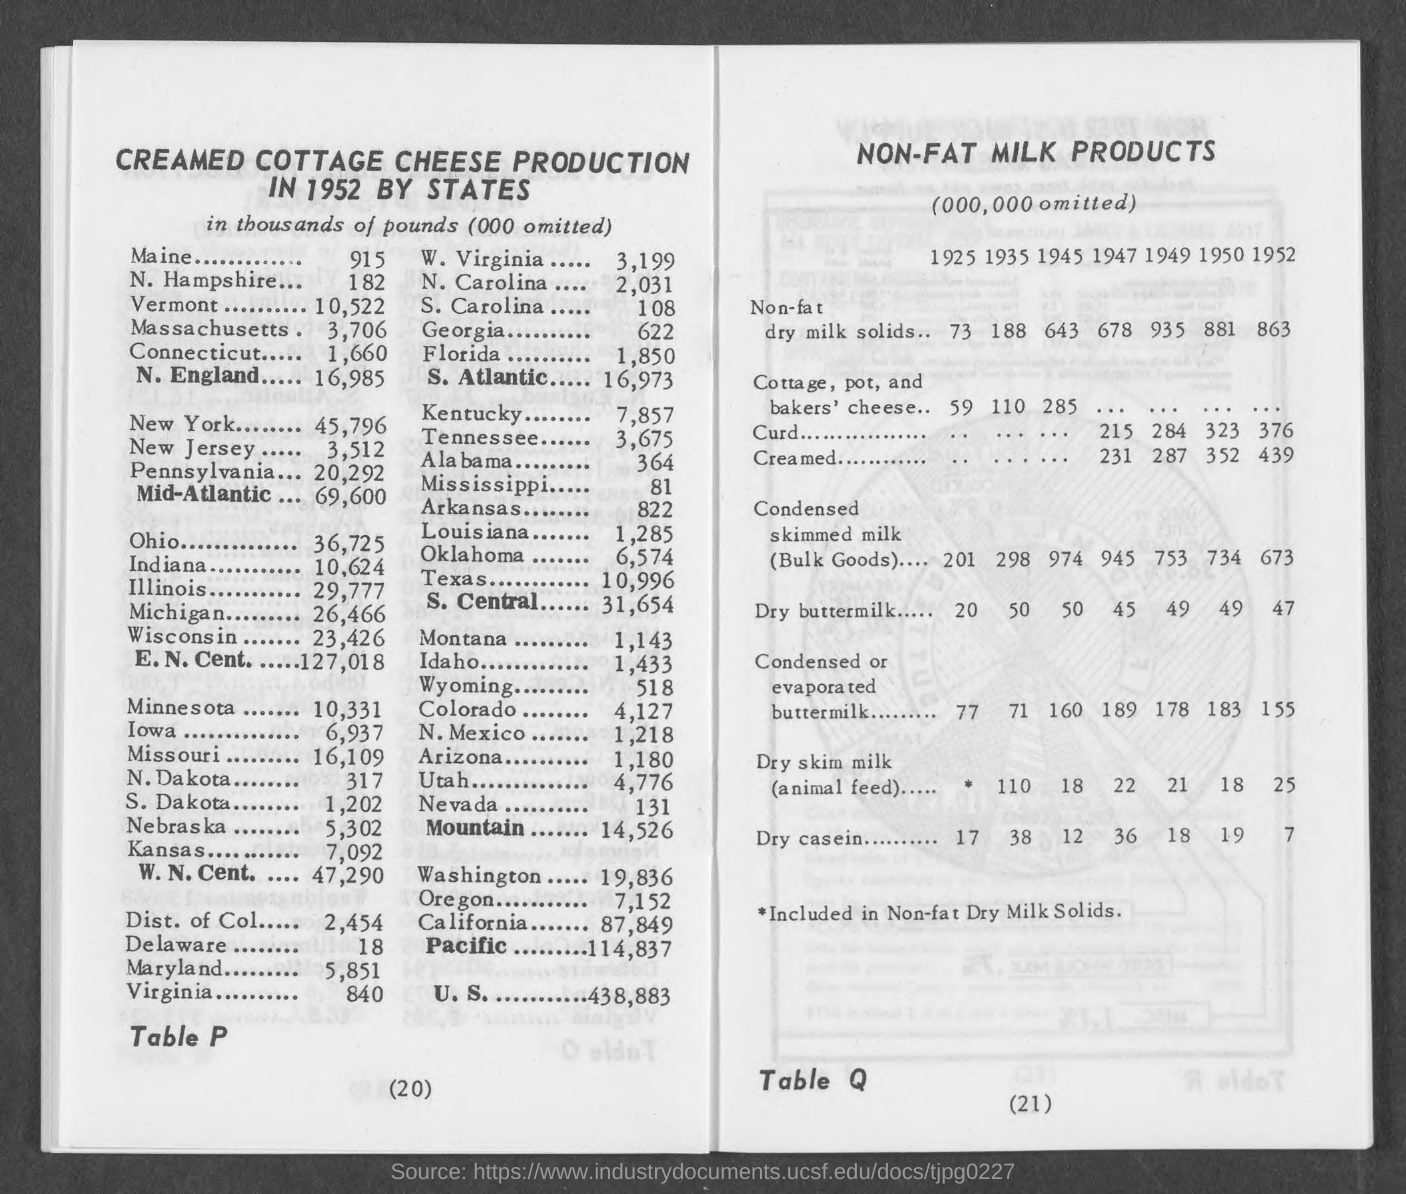Highlight a few significant elements in this photo. Norfolk Hampshire produces approximately 182 thousand pounds of milk. Ohio produced approximately 36,725 thousand pounds of milk in the year 2020. Indiana produces approximately 10,624 metric tons of milk annually. Connecticut produced approximately 1,660 thousand pounds of milk in the past year. Massachusetts produces approximately 3,706 tons of milk each year. 